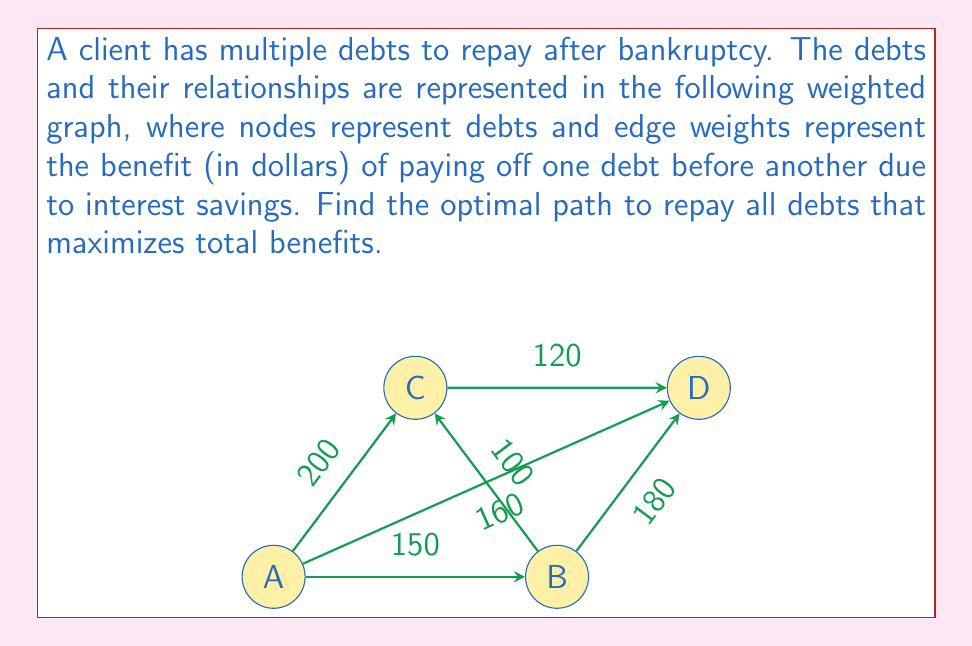Solve this math problem. To find the optimal path that maximizes total benefits, we need to use Kruskal's algorithm to find the maximum spanning tree of the graph. This will give us the path that includes all debts while maximizing the total benefit.

Step 1: Sort the edges by weight in descending order:
1. A-C: 200
2. B-D: 180
3. A-D: 160
4. A-B: 150
5. C-D: 120
6. B-C: 100

Step 2: Apply Kruskal's algorithm:
1. Add A-C (200)
2. Add B-D (180)
3. Add A-B (150) (A-D is skipped as it would create a cycle)

The maximum spanning tree is now complete with edges A-C, B-D, and A-B.

Step 3: Determine the optimal path:
Starting from any node, traverse the tree to visit all nodes. One possible path is:
A → C → A → B → D

The total benefit of this path is: 200 + 150 + 180 = $530

Therefore, the optimal debt repayment order is: A, C, B, D (or D, B, C, A in reverse order).
Answer: Optimal path: A → C → A → B → D, with total benefit $530 